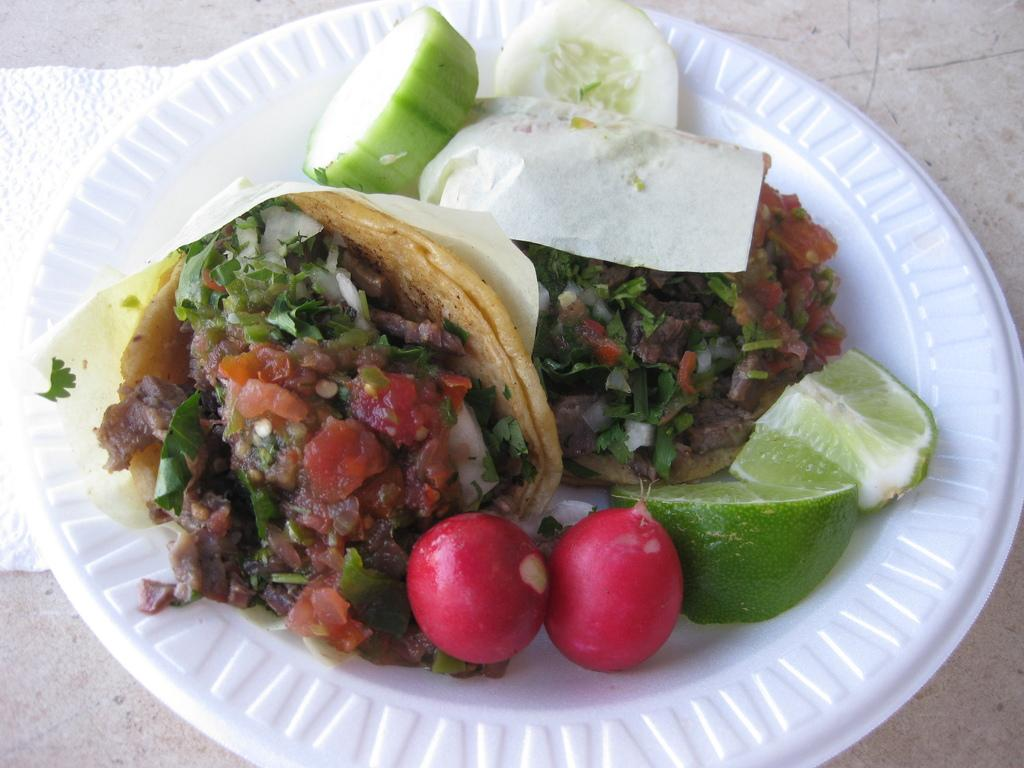What color is the plate that is visible in the image? The plate in the image is white. What is on the plate in the image? There are food items on the plate. What type of alarm is present on the plate in the image? There is no alarm present on the plate in the image; it only contains food items. 